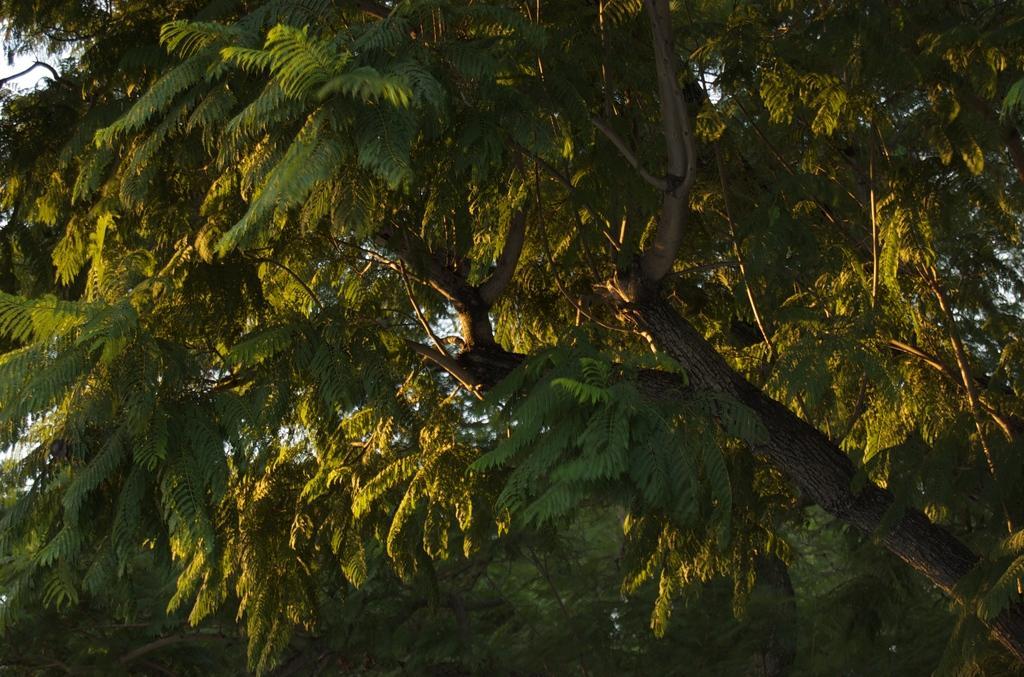Describe this image in one or two sentences. This picture contains trees which are green in color. 